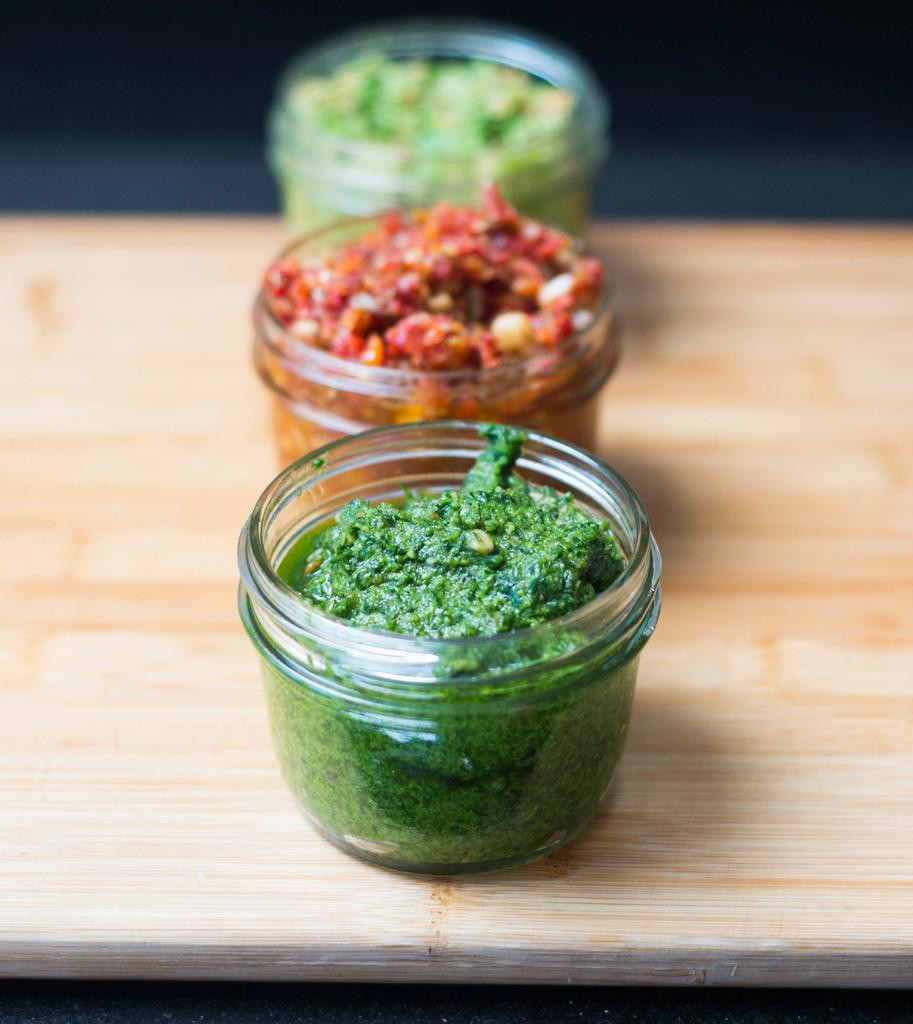What is contained in the glass containers in the image? There are food items in three glass containers in the image. What can be inferred about the object on which the glass containers are placed? The glass containers are placed on an object, but the specific nature of the object is not clear from the facts provided. What can be said about the background of the image? The background of the image is blurred. How many rabbits can be seen playing with a vase in the image? There are no rabbits or vases present in the image. What type of list is visible on the table in the image? There is no list visible in the image. 